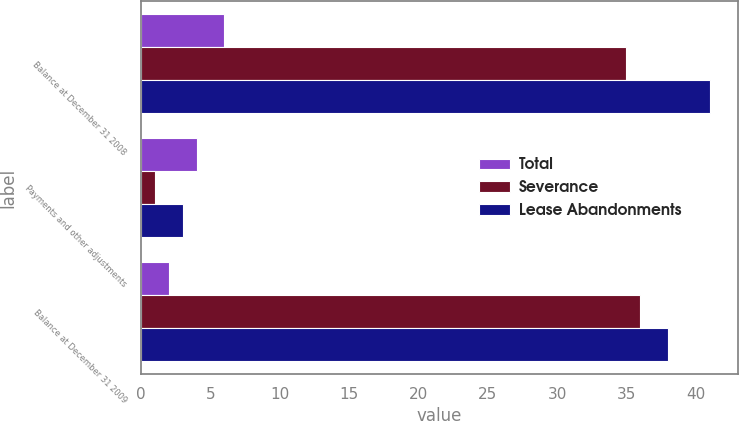Convert chart. <chart><loc_0><loc_0><loc_500><loc_500><stacked_bar_chart><ecel><fcel>Balance at December 31 2008<fcel>Payments and other adjustments<fcel>Balance at December 31 2009<nl><fcel>Total<fcel>6<fcel>4<fcel>2<nl><fcel>Severance<fcel>35<fcel>1<fcel>36<nl><fcel>Lease Abandonments<fcel>41<fcel>3<fcel>38<nl></chart> 